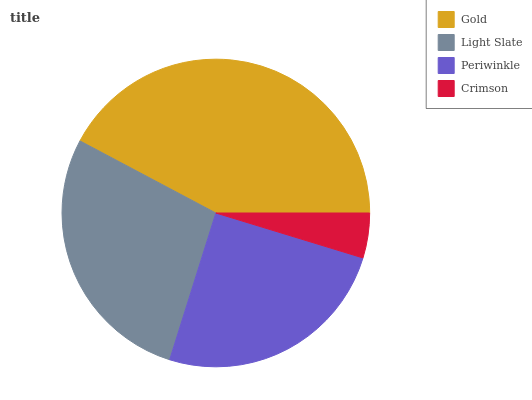Is Crimson the minimum?
Answer yes or no. Yes. Is Gold the maximum?
Answer yes or no. Yes. Is Light Slate the minimum?
Answer yes or no. No. Is Light Slate the maximum?
Answer yes or no. No. Is Gold greater than Light Slate?
Answer yes or no. Yes. Is Light Slate less than Gold?
Answer yes or no. Yes. Is Light Slate greater than Gold?
Answer yes or no. No. Is Gold less than Light Slate?
Answer yes or no. No. Is Light Slate the high median?
Answer yes or no. Yes. Is Periwinkle the low median?
Answer yes or no. Yes. Is Periwinkle the high median?
Answer yes or no. No. Is Light Slate the low median?
Answer yes or no. No. 